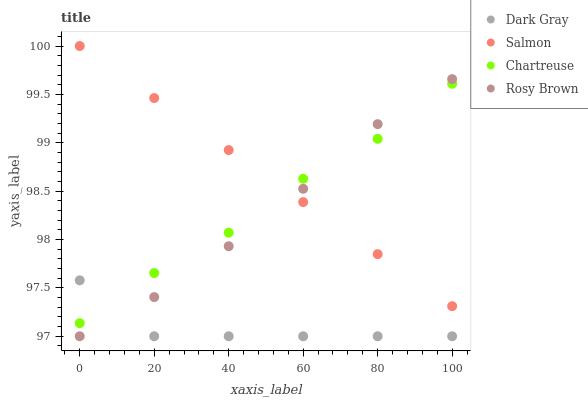Does Dark Gray have the minimum area under the curve?
Answer yes or no. Yes. Does Salmon have the maximum area under the curve?
Answer yes or no. Yes. Does Chartreuse have the minimum area under the curve?
Answer yes or no. No. Does Chartreuse have the maximum area under the curve?
Answer yes or no. No. Is Salmon the smoothest?
Answer yes or no. Yes. Is Dark Gray the roughest?
Answer yes or no. Yes. Is Chartreuse the smoothest?
Answer yes or no. No. Is Chartreuse the roughest?
Answer yes or no. No. Does Dark Gray have the lowest value?
Answer yes or no. Yes. Does Chartreuse have the lowest value?
Answer yes or no. No. Does Salmon have the highest value?
Answer yes or no. Yes. Does Chartreuse have the highest value?
Answer yes or no. No. Is Dark Gray less than Salmon?
Answer yes or no. Yes. Is Salmon greater than Dark Gray?
Answer yes or no. Yes. Does Rosy Brown intersect Dark Gray?
Answer yes or no. Yes. Is Rosy Brown less than Dark Gray?
Answer yes or no. No. Is Rosy Brown greater than Dark Gray?
Answer yes or no. No. Does Dark Gray intersect Salmon?
Answer yes or no. No. 